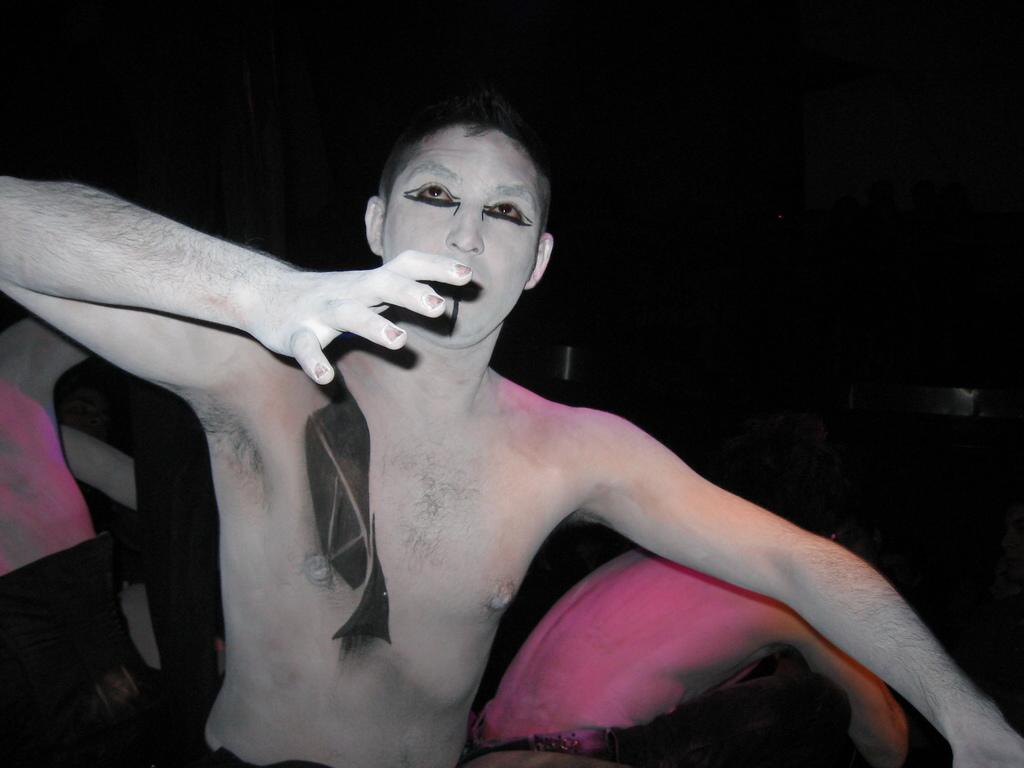What time of day is the image taken? The image is taken during night time. Can you describe the person in the foreground of the image? There is a person with painting on their body in the image. What else can be seen in the background of the image? There are other persons in the background of the image. What type of steel is being used by the person in the image? There is no steel present in the image; the person has painting on their body. Can you describe the scissors being held by the person in the image? There are no scissors present in the image. 